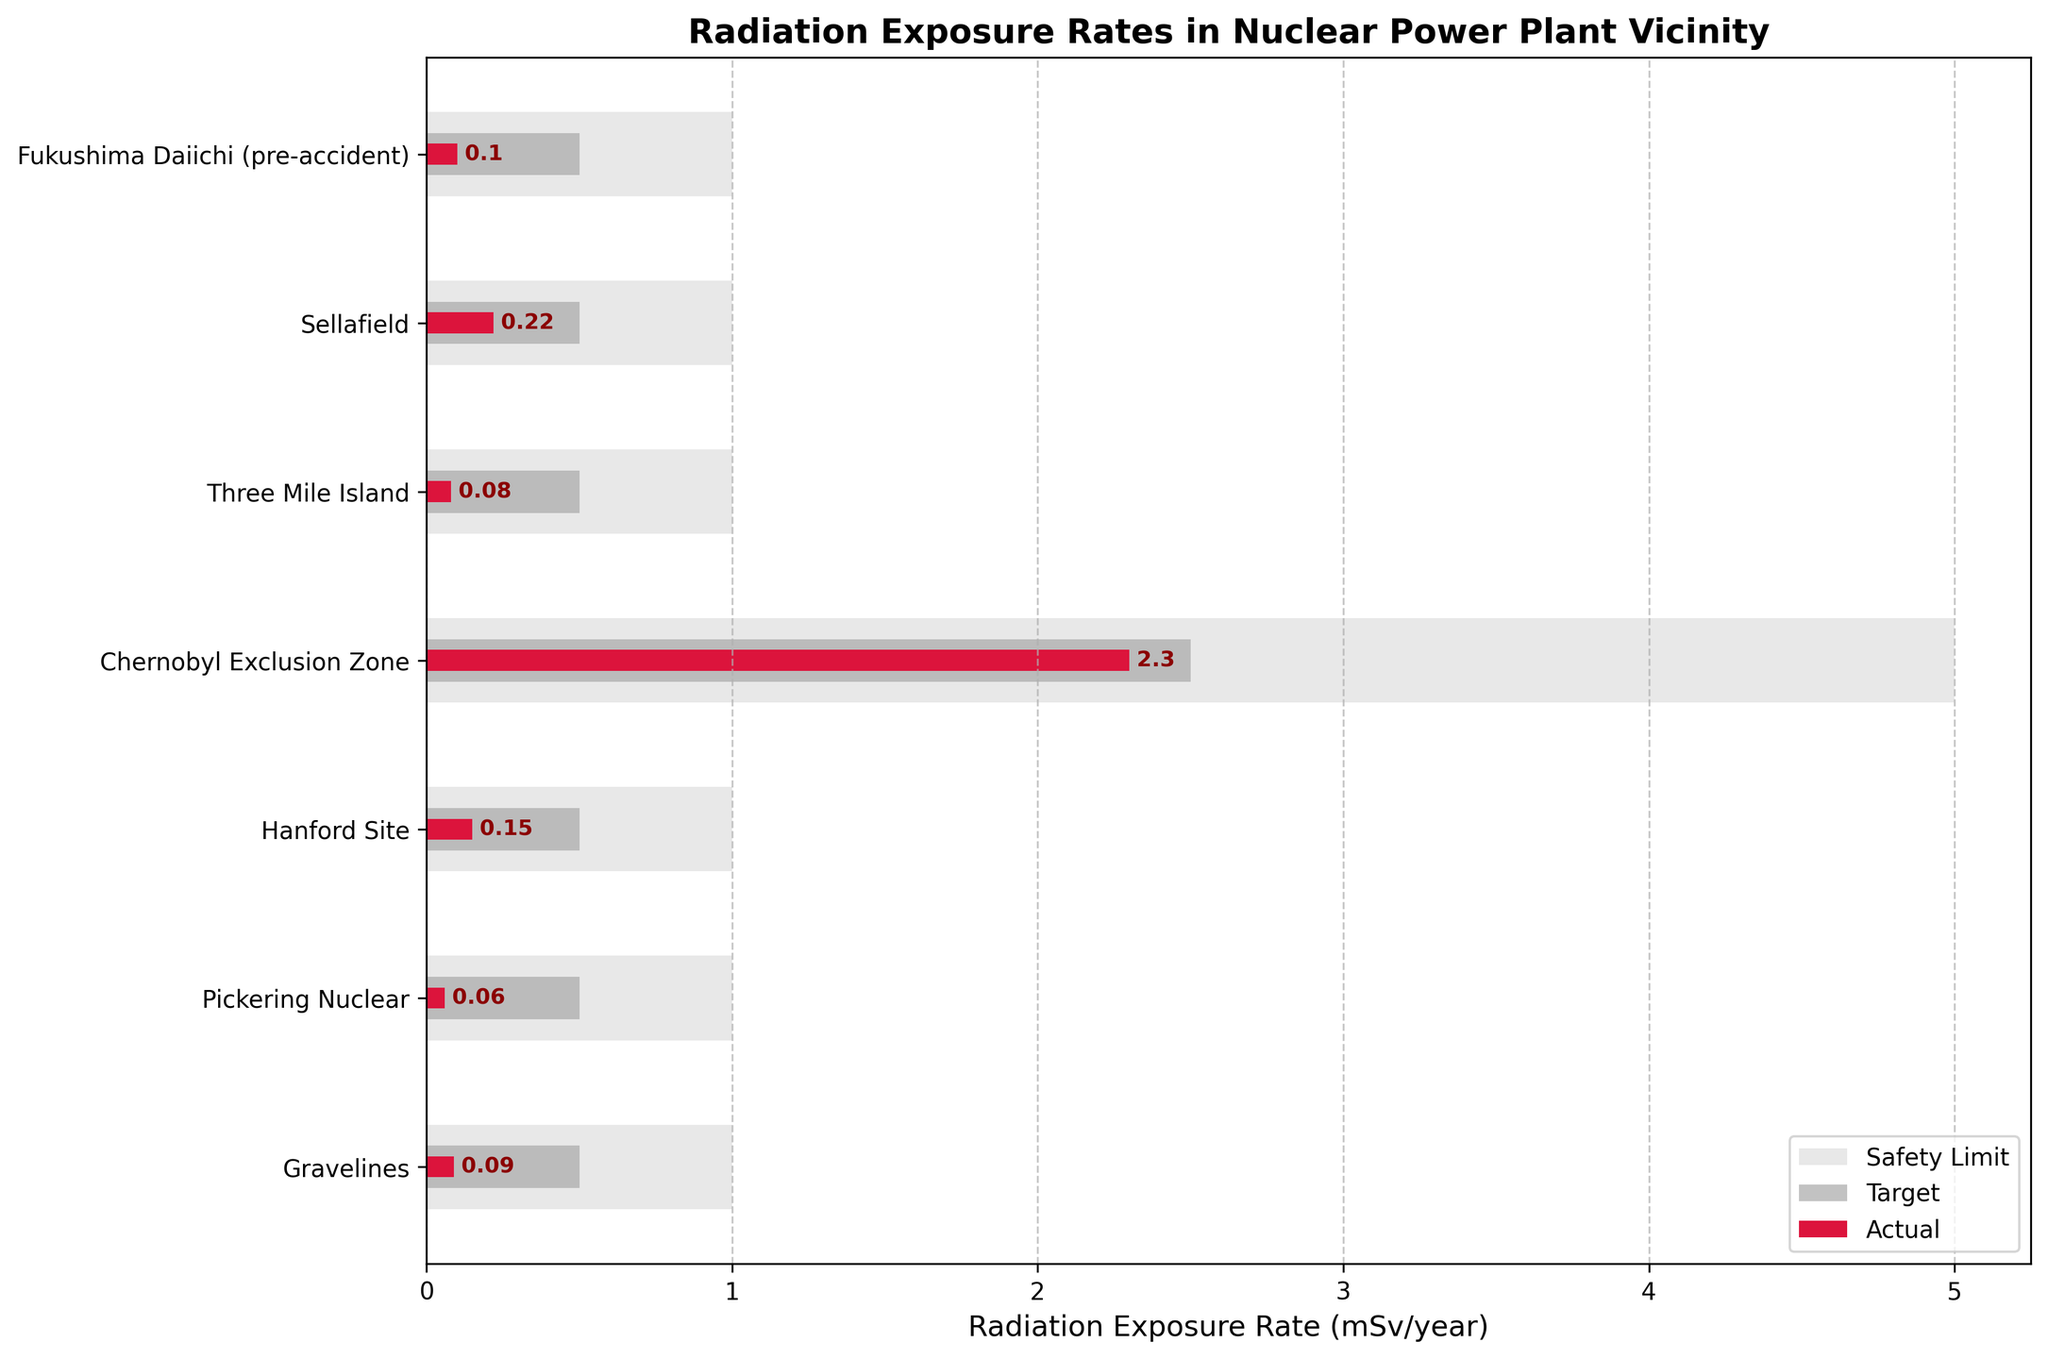what is the title of the figure? The title is typically located at the top center of the figure. It provides a summary of what the figure is about. Here, the title is likely shown in a bold and larger font size.
Answer: Radiation Exposure Rates in Nuclear Power Plant Vicinity What is the highest recorded radiation exposure rate among the locations? To find the highest value, compare the 'Actual' values for each plant. The highest value is the largest bar among the crimson bars.
Answer: 2.3 mSv/year at the Chernobyl Exclusion Zone Which nuclear power plant has the lowest actual radiation exposure rate? Compare the crimson bars representing the 'Actual' values for each plant. The shortest bar indicates the lowest value.
Answer: Pickering Nuclear at 0.06 mSv/year How many locations have actual exposure rates higher than the target value? Compare each 'Actual' value to the 'Target' value. Count how many times the 'Actual' value exceeds the 'Target' value.
Answer: 4 locations (Fukushima Daiichi (pre-accident), Sellafield, Chernobyl Exclusion Zone, and Hanford Site) Which plant exceeds its safety limit? Look at the bars for 'Actual' values and see if any exceed the length of the corresponding 'Safety Limit' bar.
Answer: Chernobyl Exclusion Zone What is the difference in actual radiation exposure rates between Fukushima Daiichi (pre-accident) and Three Mile Island? Subtract the 'Actual' value of Three Mile Island from that of Fukushima Daiichi (pre-accident).
Answer: 0.1 - 0.08 = 0.02 mSv/year Compare the actual radiation exposure rates of Hanford Site and Gravelines. Which is higher? Compare the lengths of the crimson bars for Hanford Site and Gravelines. The longer bar indicates the higher value.
Answer: Hanford Site at 0.15 mSv/year is higher than Gravelines at 0.09 mSv/year How does the actual exposure at Sellafield compare to the target exposure rate? Compare the 'Actual' bar to the 'Target' bar for Sellafield. If the 'Actual' bar is longer, it exceeds the target.
Answer: The actual exposure at Sellafield (0.22 mSv/year) is above the target (0.5 mSv/year) 